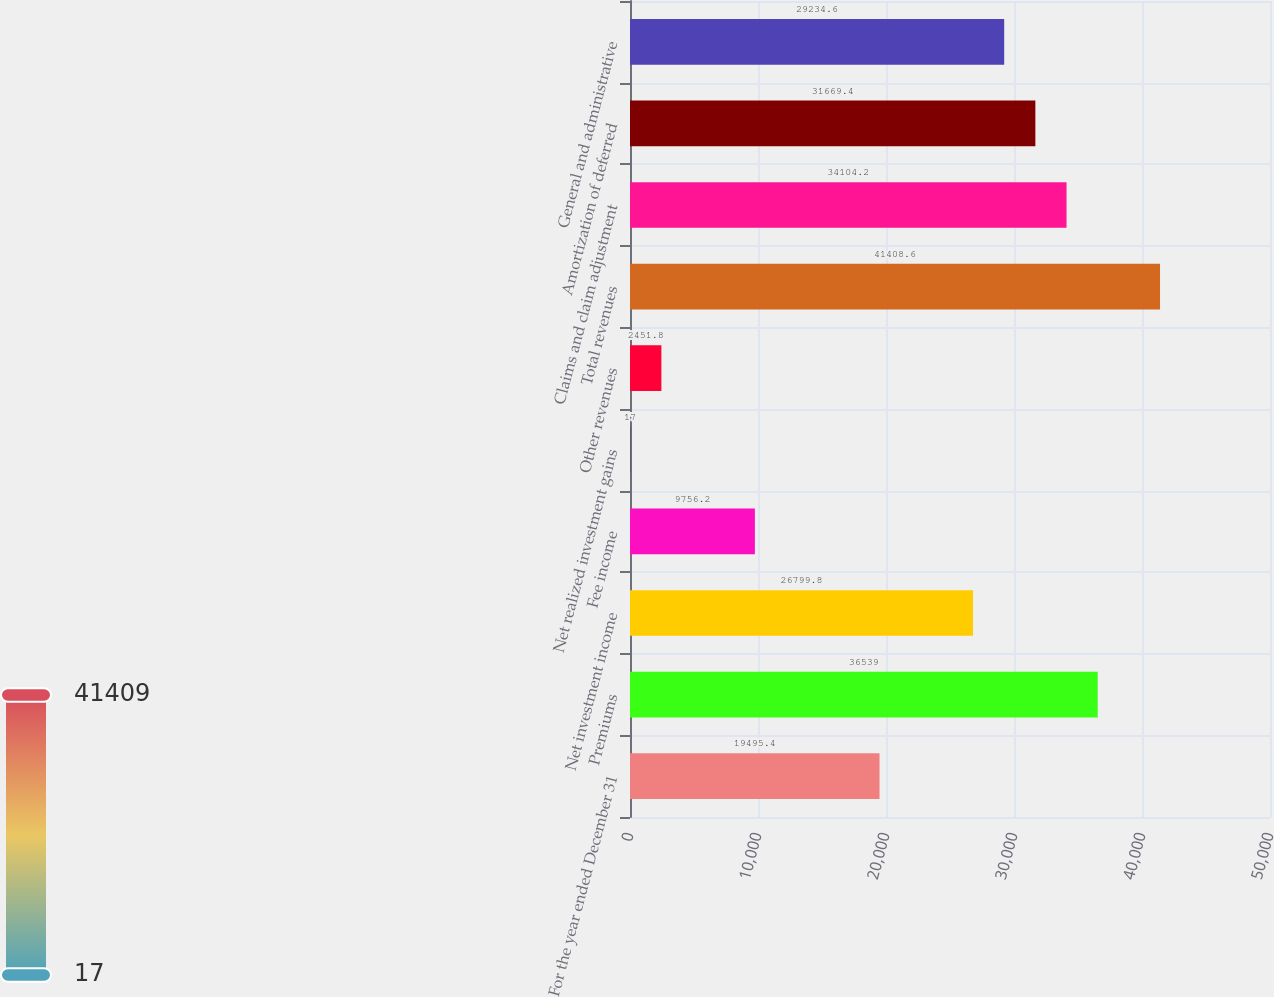<chart> <loc_0><loc_0><loc_500><loc_500><bar_chart><fcel>For the year ended December 31<fcel>Premiums<fcel>Net investment income<fcel>Fee income<fcel>Net realized investment gains<fcel>Other revenues<fcel>Total revenues<fcel>Claims and claim adjustment<fcel>Amortization of deferred<fcel>General and administrative<nl><fcel>19495.4<fcel>36539<fcel>26799.8<fcel>9756.2<fcel>17<fcel>2451.8<fcel>41408.6<fcel>34104.2<fcel>31669.4<fcel>29234.6<nl></chart> 